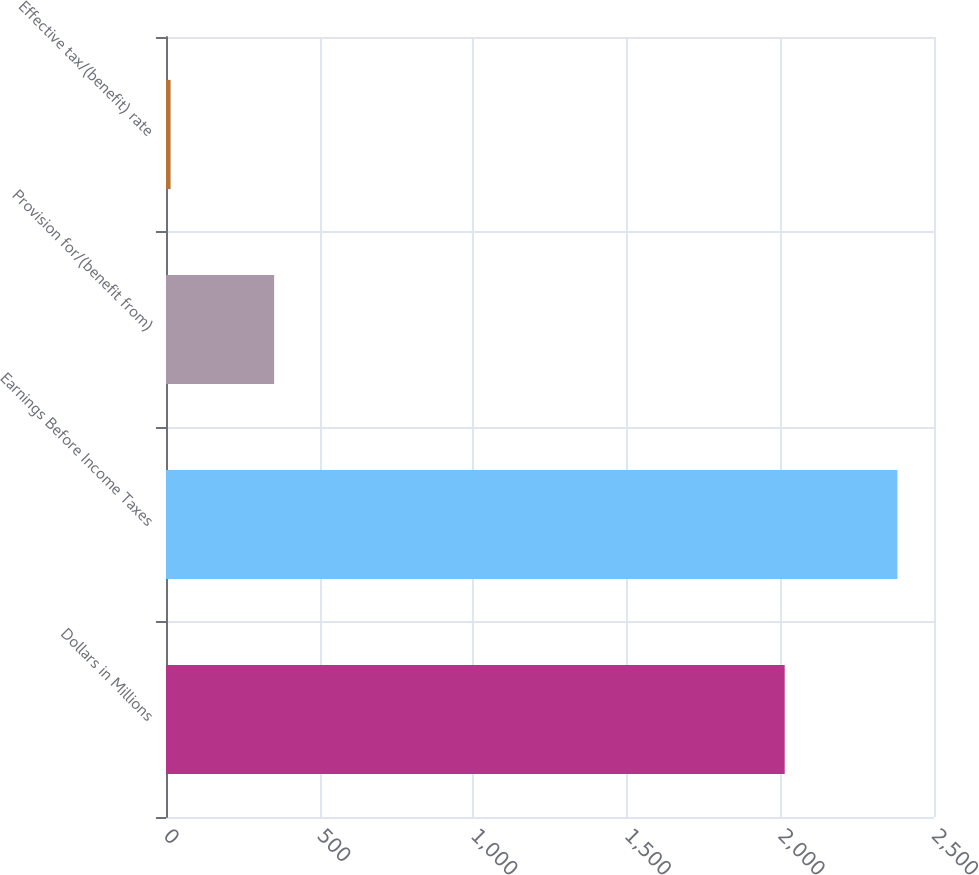<chart> <loc_0><loc_0><loc_500><loc_500><bar_chart><fcel>Dollars in Millions<fcel>Earnings Before Income Taxes<fcel>Provision for/(benefit from)<fcel>Effective tax/(benefit) rate<nl><fcel>2014<fcel>2381<fcel>352<fcel>14.8<nl></chart> 